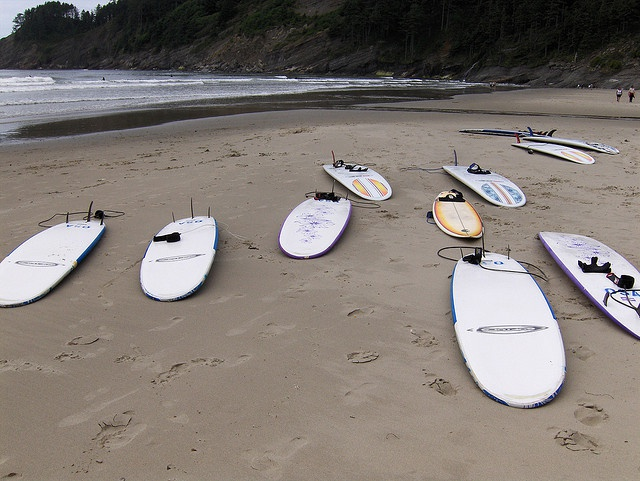Describe the objects in this image and their specific colors. I can see surfboard in lavender, lightgray, darkgray, gray, and black tones, surfboard in lavender, lightgray, black, purple, and darkgray tones, surfboard in lavender, lightgray, black, darkgray, and gray tones, surfboard in lavender, lightgray, black, darkgray, and gray tones, and surfboard in lavender, black, and darkgray tones in this image. 